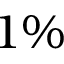<formula> <loc_0><loc_0><loc_500><loc_500>1 \%</formula> 